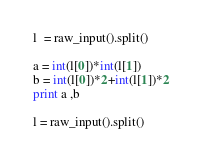<code> <loc_0><loc_0><loc_500><loc_500><_Python_>l  = raw_input().split()

a = int(l[0])*int(l[1])
b = int(l[0])*2+int(l[1])*2
print a ,b

l = raw_input().split()</code> 